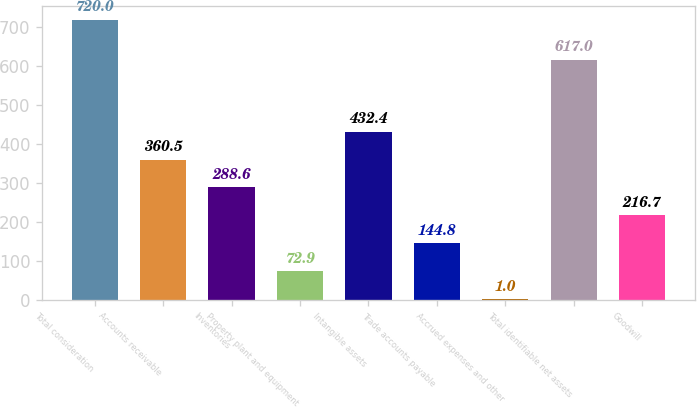<chart> <loc_0><loc_0><loc_500><loc_500><bar_chart><fcel>Total consideration<fcel>Accounts receivable<fcel>Inventories<fcel>Property plant and equipment<fcel>Intangible assets<fcel>Trade accounts payable<fcel>Accrued expenses and other<fcel>Total identifiable net assets<fcel>Goodwill<nl><fcel>720<fcel>360.5<fcel>288.6<fcel>72.9<fcel>432.4<fcel>144.8<fcel>1<fcel>617<fcel>216.7<nl></chart> 